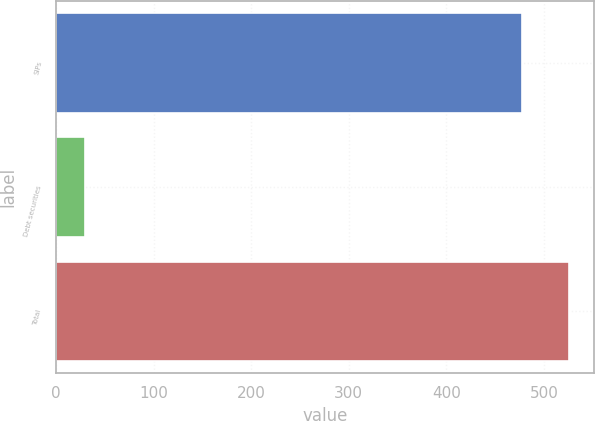<chart> <loc_0><loc_0><loc_500><loc_500><bar_chart><fcel>SIPs<fcel>Debt securities<fcel>Total<nl><fcel>477<fcel>29.7<fcel>525.33<nl></chart> 